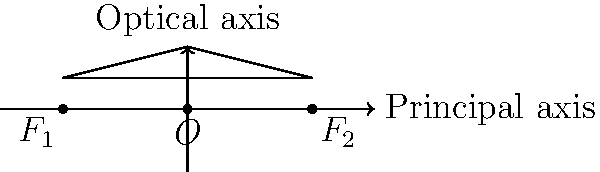In the ray diagram shown, a convex lens is represented with its optical center $O$ and two focal points $F_1$ and $F_2$. If the distance between the focal points is 4 cm, what is the focal length of the lens? To determine the focal length of a convex lens using a ray diagram, we need to follow these steps:

1. Identify the key points in the diagram:
   - $O$ is the optical center of the lens
   - $F_1$ and $F_2$ are the focal points on either side of the lens

2. Recall that the focal length is the distance between the optical center and either focal point.

3. Observe that the distance between $F_1$ and $F_2$ is given as 4 cm.

4. Recognize that the optical center $O$ is located exactly halfway between $F_1$ and $F_2$ for a symmetrical convex lens.

5. Calculate the focal length:
   - Total distance between focal points = 4 cm
   - Focal length = Half of the total distance
   - Focal length = $\frac{4 \text{ cm}}{2} = 2 \text{ cm}$

Therefore, the focal length of the convex lens is 2 cm.
Answer: 2 cm 